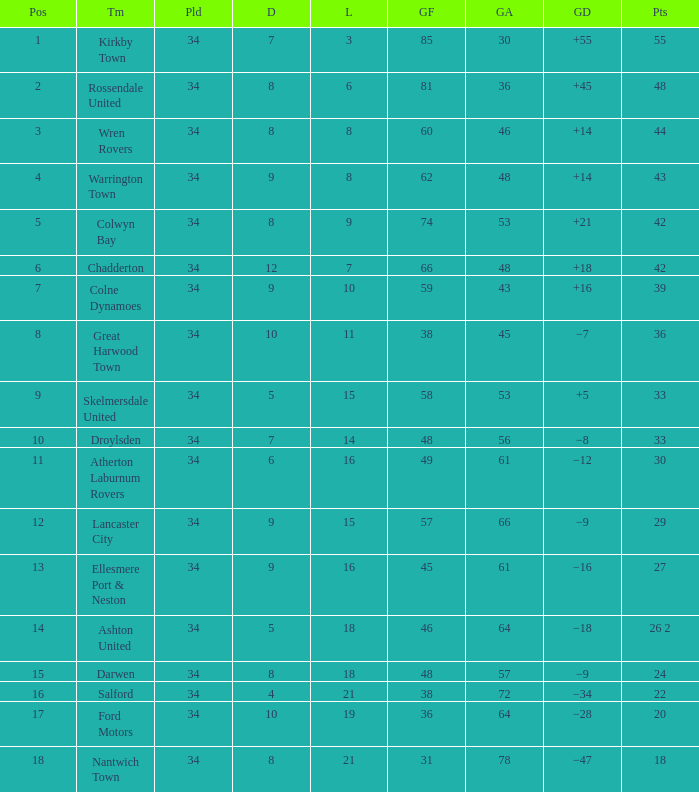What is the smallest number of goals against when there are 1 of 18 points, and more than 8 are drawn? None. 